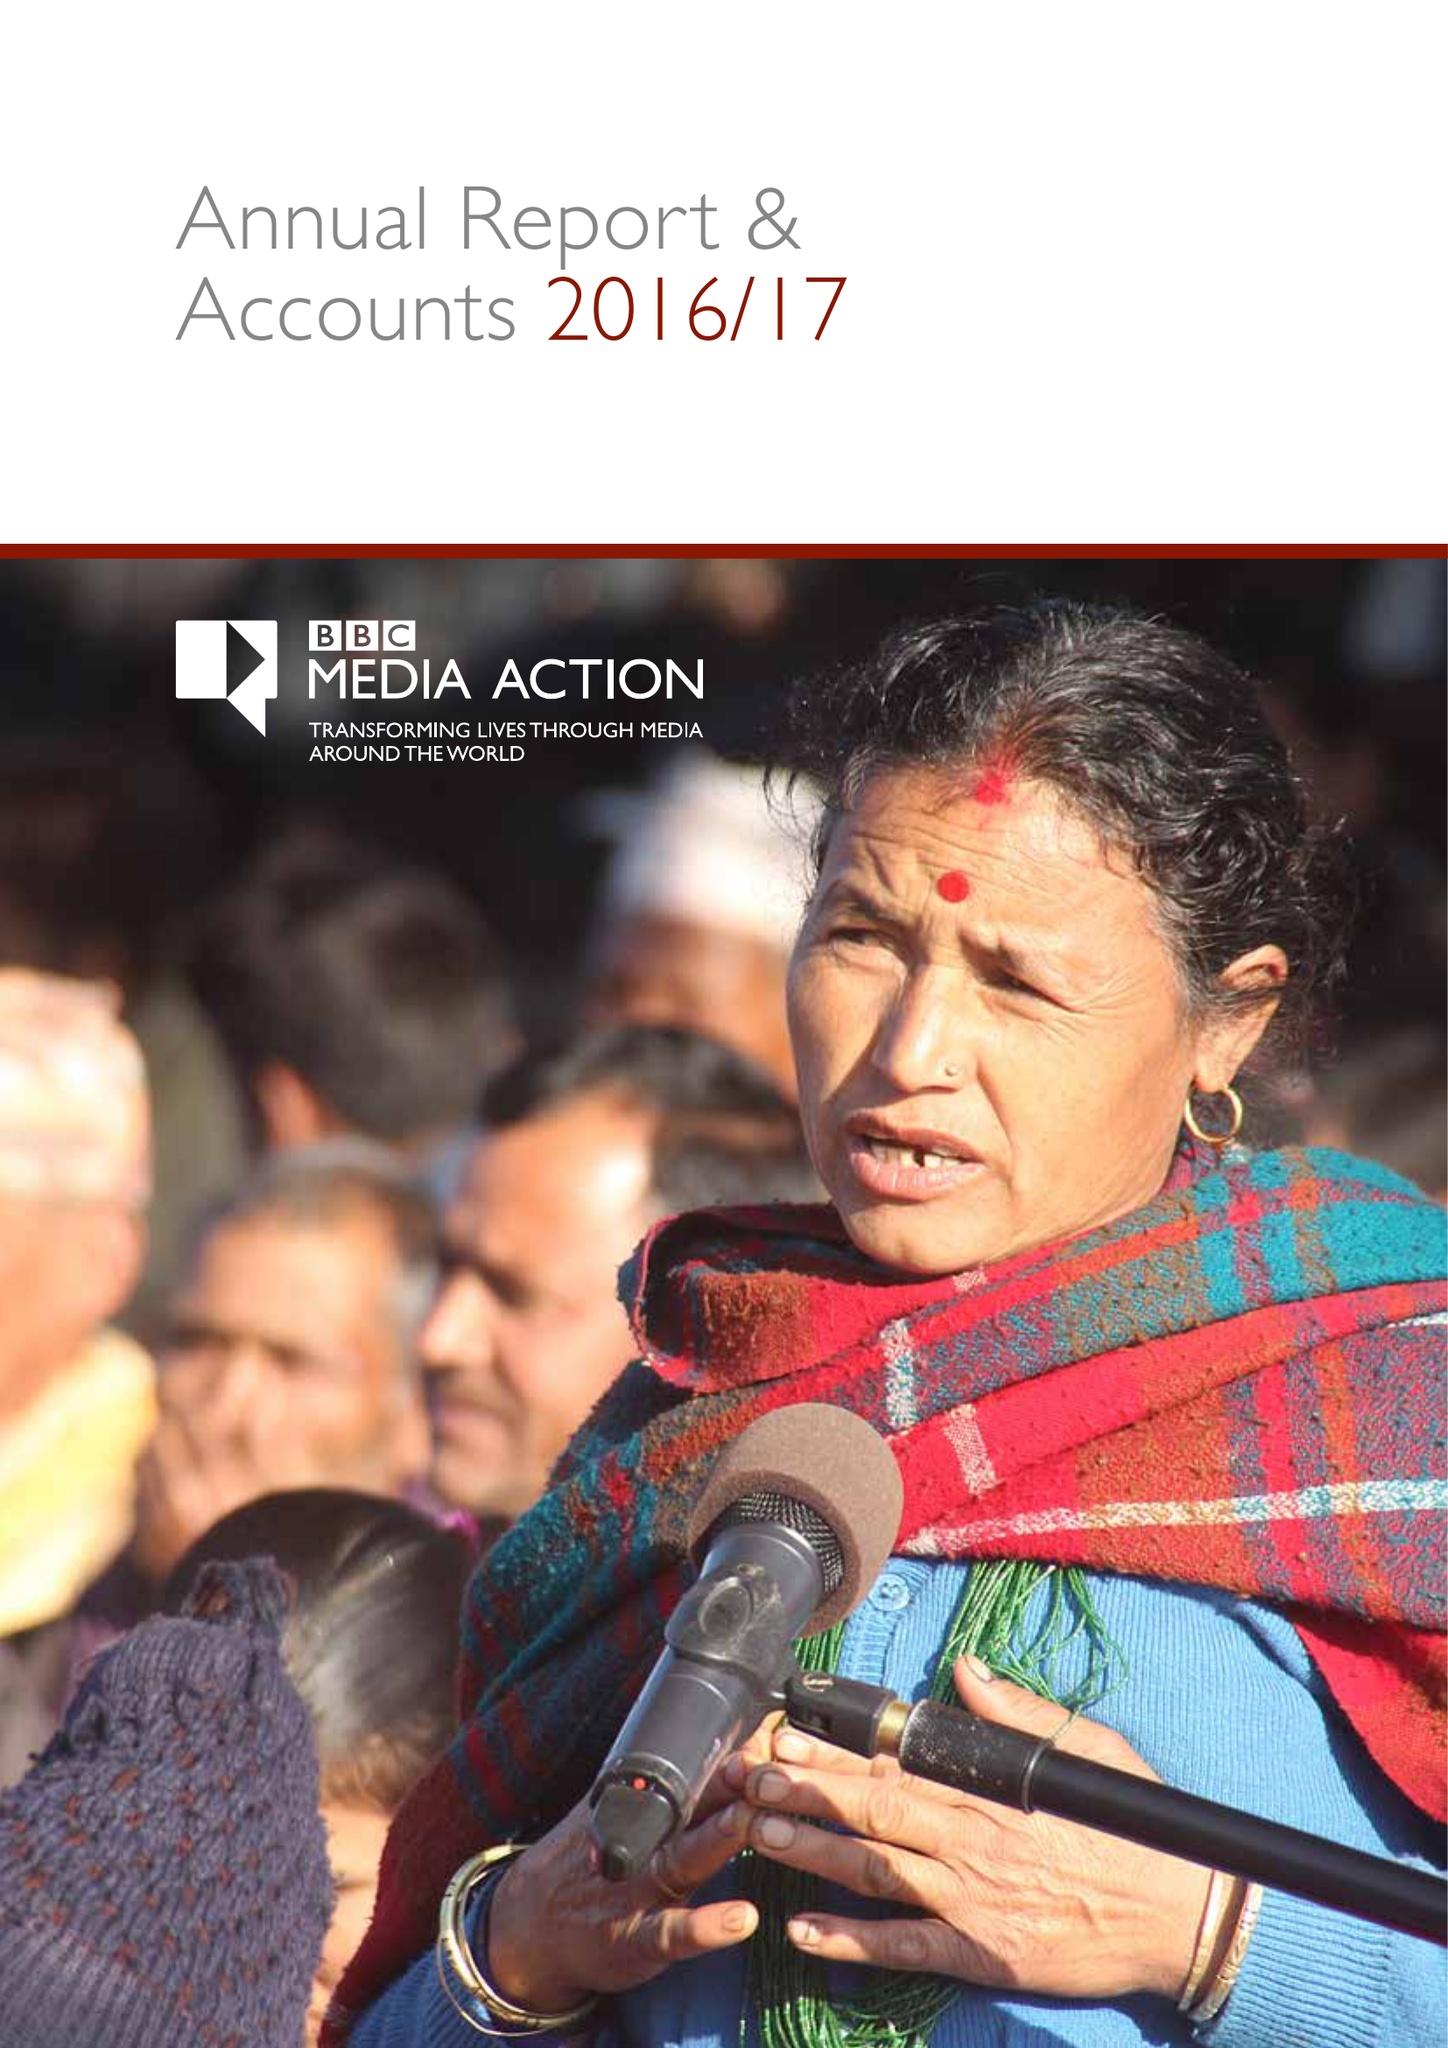What is the value for the address__post_town?
Answer the question using a single word or phrase. LONDON 